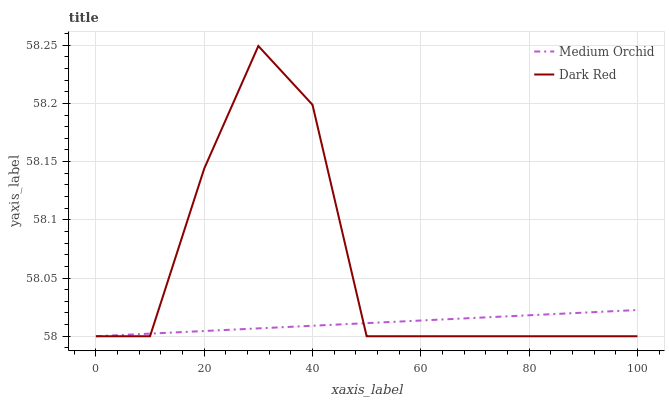Does Medium Orchid have the minimum area under the curve?
Answer yes or no. Yes. Does Dark Red have the maximum area under the curve?
Answer yes or no. Yes. Does Medium Orchid have the maximum area under the curve?
Answer yes or no. No. Is Medium Orchid the smoothest?
Answer yes or no. Yes. Is Dark Red the roughest?
Answer yes or no. Yes. Is Medium Orchid the roughest?
Answer yes or no. No. Does Dark Red have the lowest value?
Answer yes or no. Yes. Does Dark Red have the highest value?
Answer yes or no. Yes. Does Medium Orchid have the highest value?
Answer yes or no. No. Does Dark Red intersect Medium Orchid?
Answer yes or no. Yes. Is Dark Red less than Medium Orchid?
Answer yes or no. No. Is Dark Red greater than Medium Orchid?
Answer yes or no. No. 